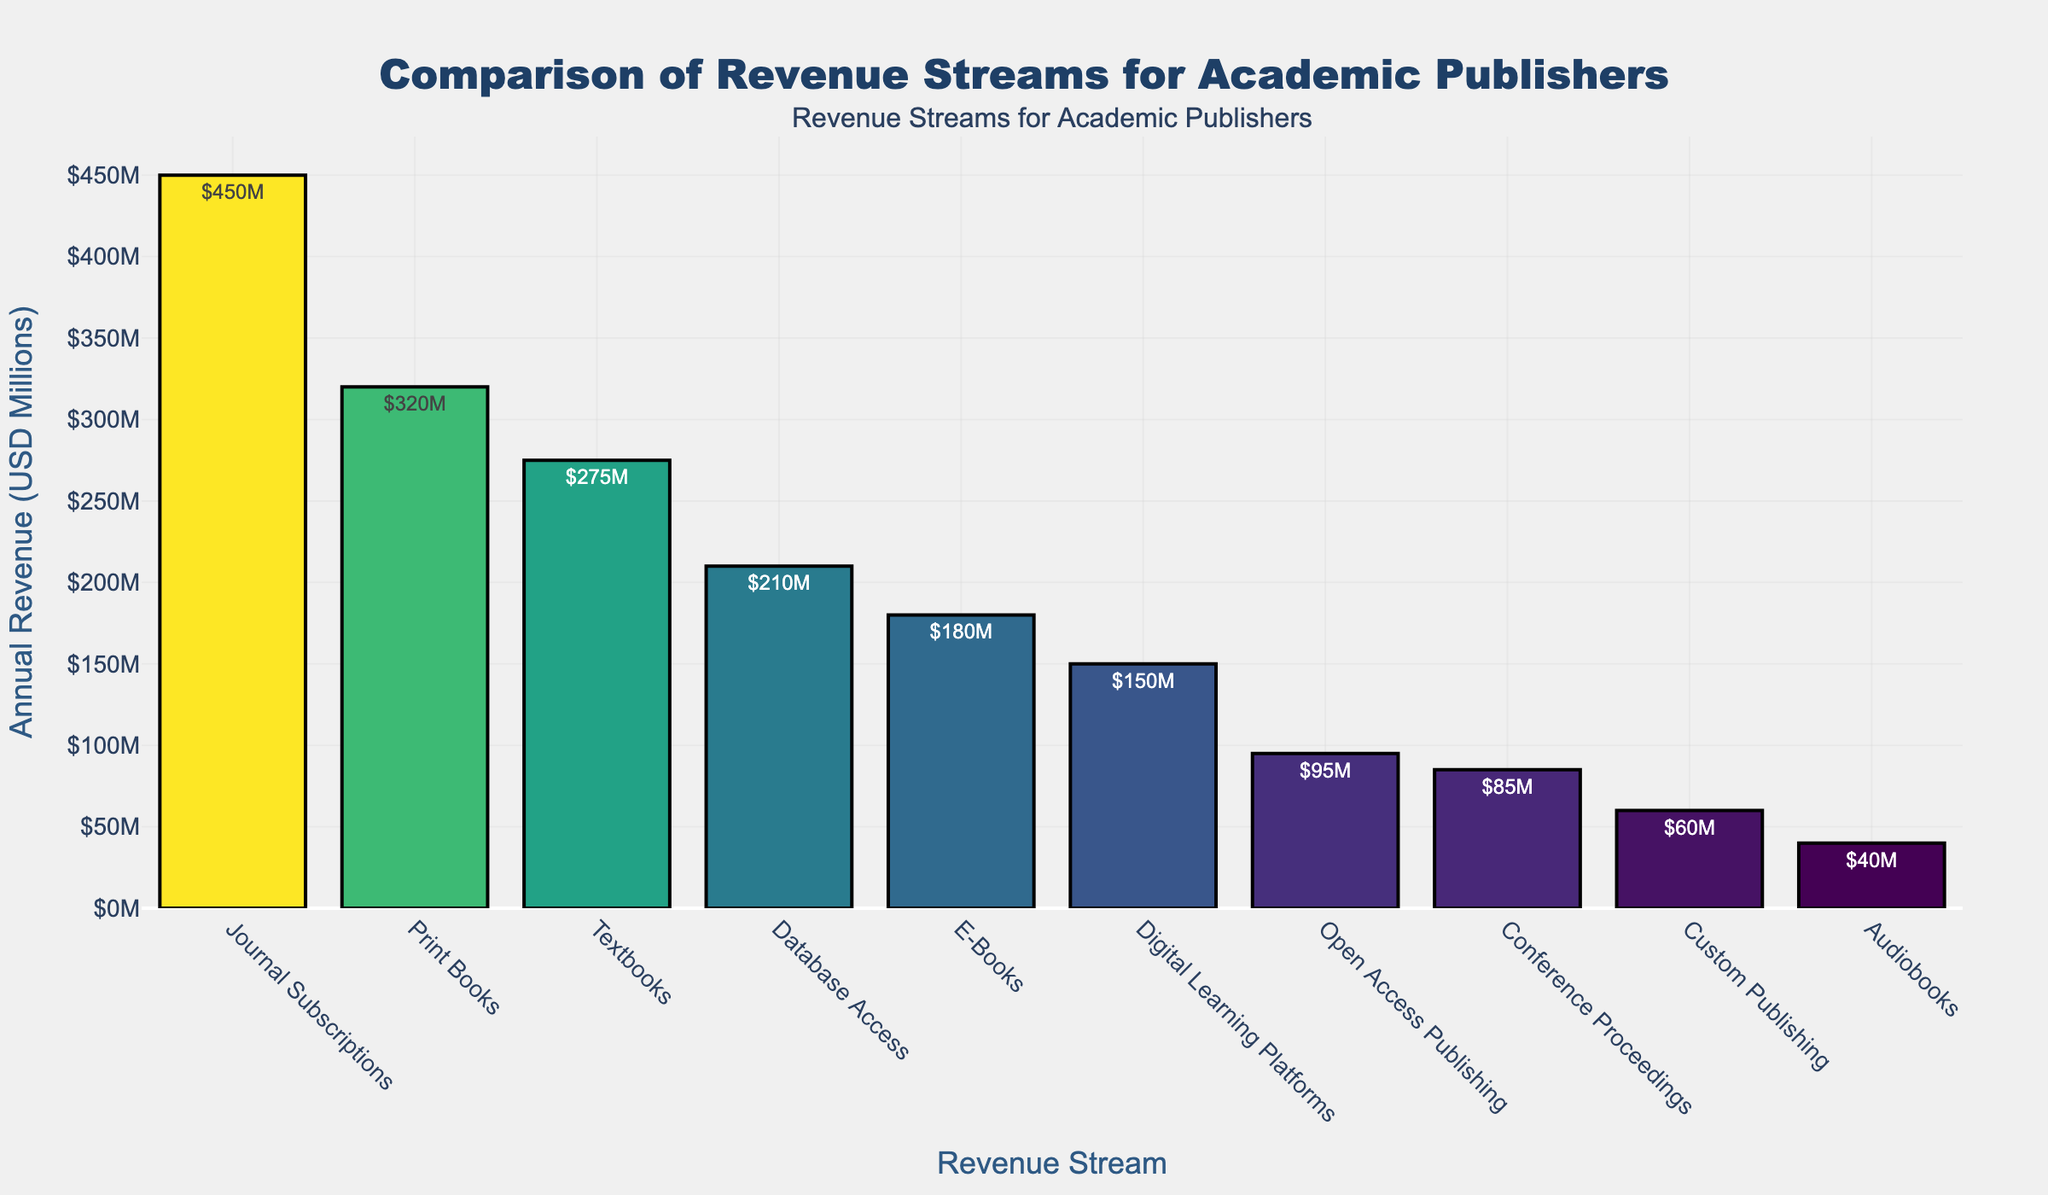What revenue stream generates the highest annual revenue? The bar representing "Journal Subscriptions" is the tallest, indicating it has the highest revenue.
Answer: Journal Subscriptions Which revenue stream has the lowest annual revenue? The shortest bar corresponds to "Audiobooks", indicating it has the lowest revenue.
Answer: Audiobooks How much more revenue do print books generate compared to e-books? The bar for "Print Books" is $320M, and for "E-Books" it is $180M. Subtracting $180M from $320M gives us $140M.
Answer: $140M What is the combined annual revenue of open access publishing, conference proceedings, and custom publishing? The bars for "Open Access Publishing," "Conference Proceedings," and "Custom Publishing" show revenues of $95M, $85M, and $60M, respectively. Adding these results in $95M + $85M + $60M = $240M.
Answer: $240M Which two revenue streams have the closest annual revenue figures and what's the difference between them? "Digital Learning Platforms" ($150M) and "E-Books" ($180M) are closest to each other. The difference between them is $180M - $150M = $30M.
Answer: E-Books and Digital Learning Platforms, $30M How much more revenue does journal subscriptions generate than database access? The bar for "Journal Subscriptions" is $450M, and for "Database Access" it is $210M. Subtracting $210M from $450M gives us $240M.
Answer: $240M What is the average annual revenue across all revenue streams? Summing the revenue values: $320M + $180M + $450M + $95M + $275M + $150M + $85M + $210M + $60M + $40M = $1865M. There are 10 revenue streams, so the average is $1865M / 10 = $186.5M.
Answer: $186.5M What is the median annual revenue of the listed revenue streams? Ordering the revenues: $40M, $60M, $85M, $95M, $150M, $180M, $210M, $275M, $320M, $450M. Since there is an even number of data points, the median is the average of the 5th and 6th values: ( $150M + $180M ) / 2 = $165M.
Answer: $165M Which revenue streams are above the average annual revenue? First, find the average annual revenue: $186.5M. The bars for "Journal Subscriptions," "Print Books," "Textbooks," and "Database Access" exceed this value.
Answer: Journal Subscriptions, Print Books, Textbooks, Database Access 